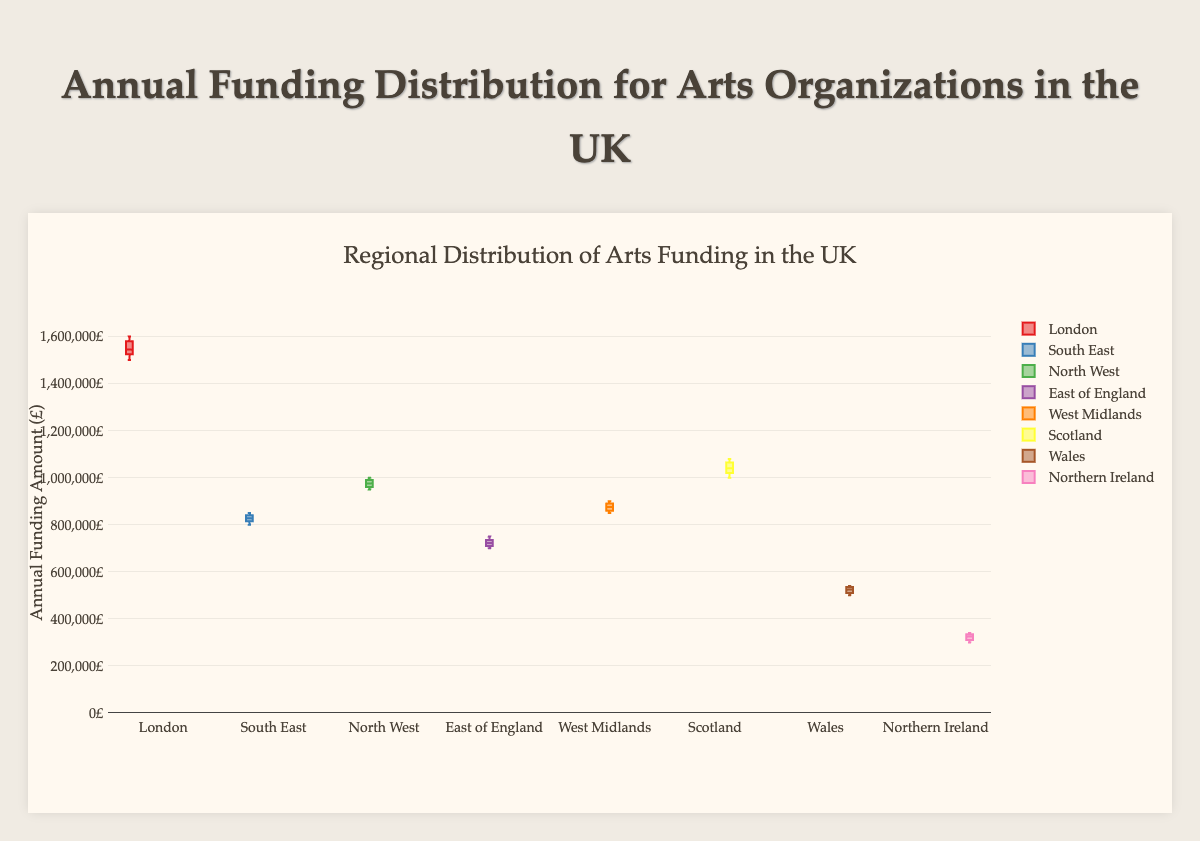What is the title of the figure? The title is located at the top of the figure and gives an overview of what the visualization represents.
Answer: Regional Distribution of Arts Funding in the UK Which region has the highest median annual funding amount? To find the region with the highest median, look at the central line inside each box—this line represents the median of the data. London has the highest median funding amount.
Answer: London What is the range of annual funding amounts for Wales? The range is found by subtracting the smallest value from the largest value within the box plot for Wales. The funding amounts range from approximately 500,000£ to 540,000£.
Answer: 40,000£ Which region has the smallest interquartile range (IQR) for its funding amounts? The IQR is the length of the box, which represents the middle 50% of the data. Northern Ireland has the smallest IQR, as its box is the shortest.
Answer: Northern Ireland What is the average of the maximum funding amounts for Scotland and London? First, find the maximum funding amount for each region, then add them together and divide by 2. Scotland's maximum is 1,080,000£ and London's maximum is 1,600,000£. The average is (1,080,000 + 1,600,000) / 2 = 1,340,000£.
Answer: 1,340,000£ Between North West and South East, which region received higher funding more frequently? Look at the position and size of the boxes. North West’s box is positioned higher on the y-axis compared to South East, indicating it frequently received higher funding amounts.
Answer: North West Among the given regions, how does the funding distribution for East of England compare to West Midlands in terms of variability? Variability is reflected in the spread of the data and the length of the whiskers. East of England has shorter whiskers and a more compact box, indicating less variability compared to the West Midlands, which has longer whiskers and a wider box.
Answer: East of England has less variability What is the combined range of funding amounts for Scotland and Wales? Calculate the individual ranges first and then add them. Scotland's range is 1,080,000£ - 1,000,000£ = 80,000£. Wales' range is 540,000£ - 500,000£ = 40,000£. The combined range is 80,000 + 40,000 = 120,000£.
Answer: 120,000£ How do the median values for East of England and South East compare? Compare the median lines inside the boxes. The median line in East of England’s box is lower on the y-axis compared to South East’s box.
Answer: South East has a higher median What are the lower quartile (Q1) values for Northern Ireland and London? Q1 is represented by the bottom line of the box in the box plot. For Northern Ireland, it's around 310,000£, and for London, it's around 1,525,000£.
Answer: Northern Ireland: 310,000£, London: 1,525,000£ 